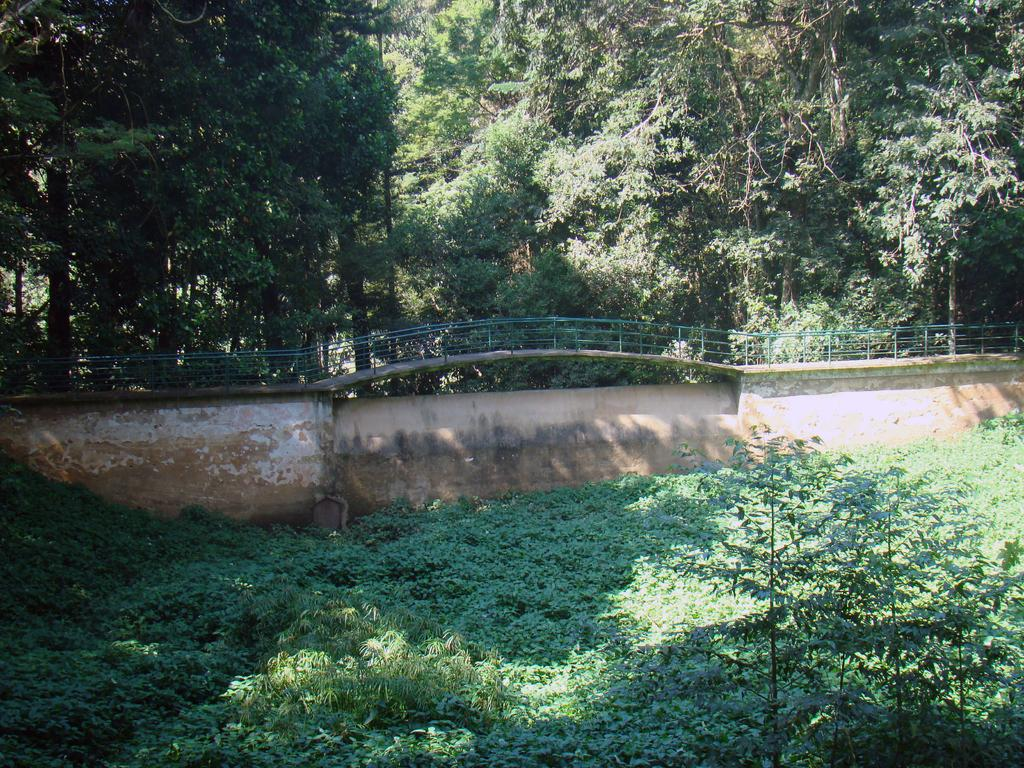What type of vegetation is at the bottom of the image? There are plants at the bottom of the image. What is located in the middle of the image? There is a fencing in the middle of the image. What can be seen in the background of the image? There are trees in the background of the image. Can you see any horns on the plants at the bottom of the image? There are no horns present on the plants in the image. What type of polish is being applied to the fencing in the middle of the image? There is no polish or any indication of polishing in the image; it only features plants, fencing, and trees. 